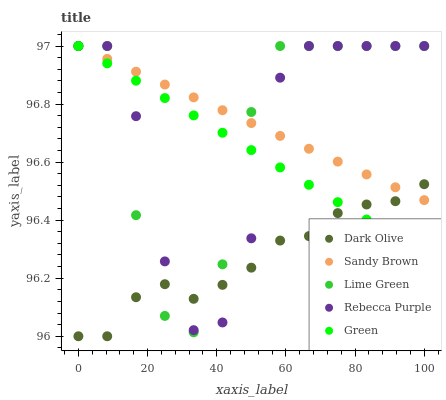Does Dark Olive have the minimum area under the curve?
Answer yes or no. Yes. Does Sandy Brown have the maximum area under the curve?
Answer yes or no. Yes. Does Lime Green have the minimum area under the curve?
Answer yes or no. No. Does Lime Green have the maximum area under the curve?
Answer yes or no. No. Is Green the smoothest?
Answer yes or no. Yes. Is Lime Green the roughest?
Answer yes or no. Yes. Is Dark Olive the smoothest?
Answer yes or no. No. Is Dark Olive the roughest?
Answer yes or no. No. Does Dark Olive have the lowest value?
Answer yes or no. Yes. Does Lime Green have the lowest value?
Answer yes or no. No. Does Rebecca Purple have the highest value?
Answer yes or no. Yes. Does Dark Olive have the highest value?
Answer yes or no. No. Does Dark Olive intersect Lime Green?
Answer yes or no. Yes. Is Dark Olive less than Lime Green?
Answer yes or no. No. Is Dark Olive greater than Lime Green?
Answer yes or no. No. 